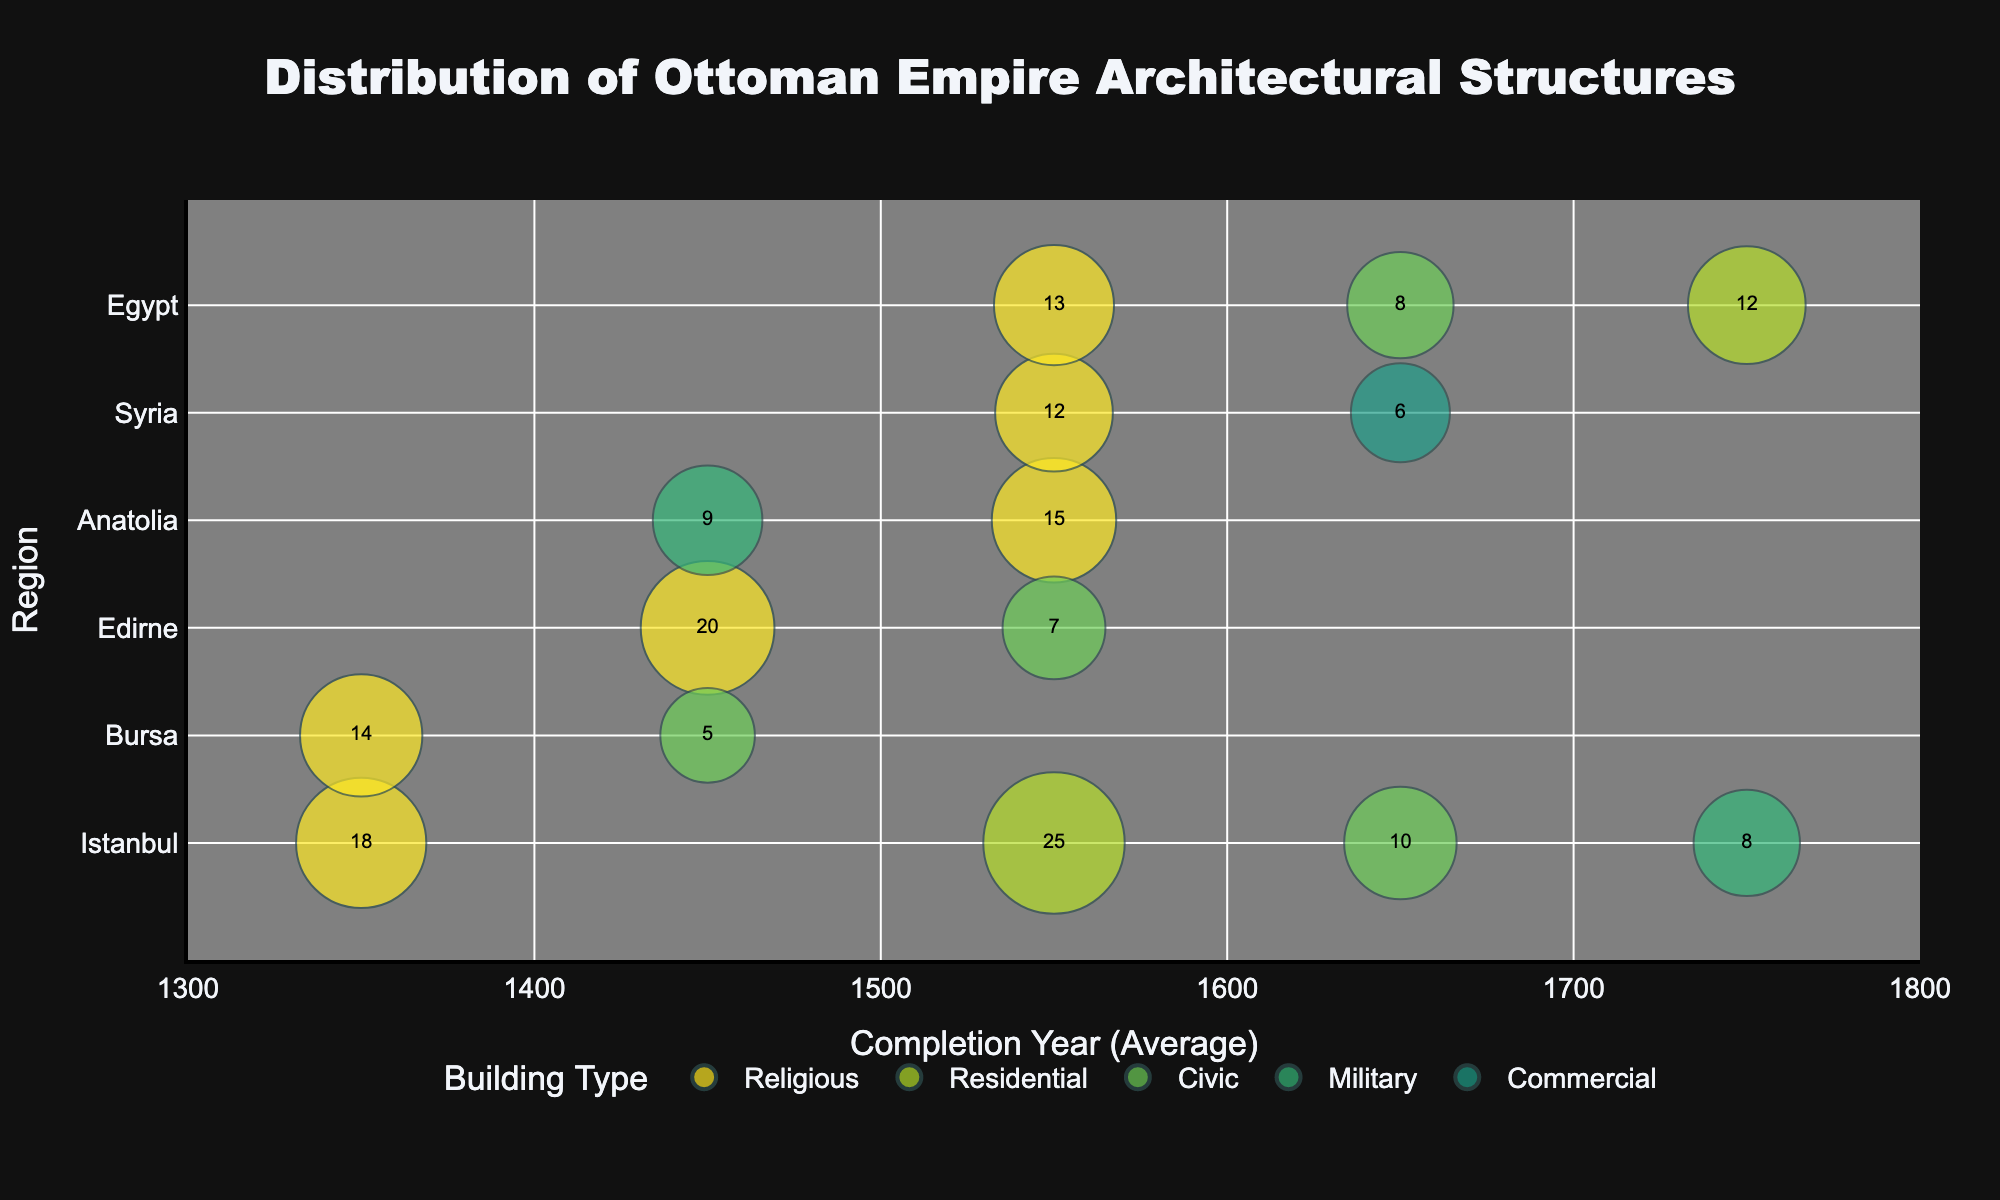What is the title of the figure? The title is displayed prominently at the top of the figure. It reads, 'Distribution of Ottoman Empire Architectural Structures'.
Answer: Distribution of Ottoman Empire Architectural Structures Which region has the highest number of religious structures completed between 1500-1600? The bubble representing religious structures in Istanbul between 1500-1600 is larger than the other similar bubbles during that period, indicating the highest number of structures.
Answer: Istanbul What is the average completion year of the military structures in Anatolia displayed in the figure? The average completion year for the military structures in Anatolia, as depicted in the figure, is located along the x-axis at the label '1450'.
Answer: 1450 Which region has the smallest bubble and what does it represent? The smallest bubble, which appears to be in Bursa, represents the Civic buildings from the period 1400-1500.
Answer: Bursa, Civic How does the number of religious structures in Istanbul between 1300-1400 compare to those in Bursa for the same period? The size of the bubble in Istanbul for religious structures between 1300-1400 is slightly larger than that in Bursa, indicating a higher number of structures in Istanbul.
Answer: Istanbul has more What's the difference between the number of residential structures in Egypt between 1700-1800 and military structures in Istanbul during the same period? The bubble for residential structures in Egypt between 1700-1800 indicates '12', and the bubble for military structures in Istanbul during the same period shows '8'. The difference is 12 - 8.
Answer: 4 Which two regions show the completion of civic structures around the year 1650? The bubbles for civic structures around 1650 appear in both Istanbul and Egypt regions.
Answer: Istanbul and Egypt Among the reported structures, which building type appears most frequently across different regions? By examining the colors and quantities of the bubbles, religious structures appear most frequently across Istanbul, Bursa, Edirne, Anatolia, Syria, and Egypt.
Answer: Religious In which time period did Edirne have religious structures built, and what's the number of such structures? The bubble representing religious structures in Edirne is positioned in the period 1400-1500 with '20' structures.
Answer: 1400-1500, 20 